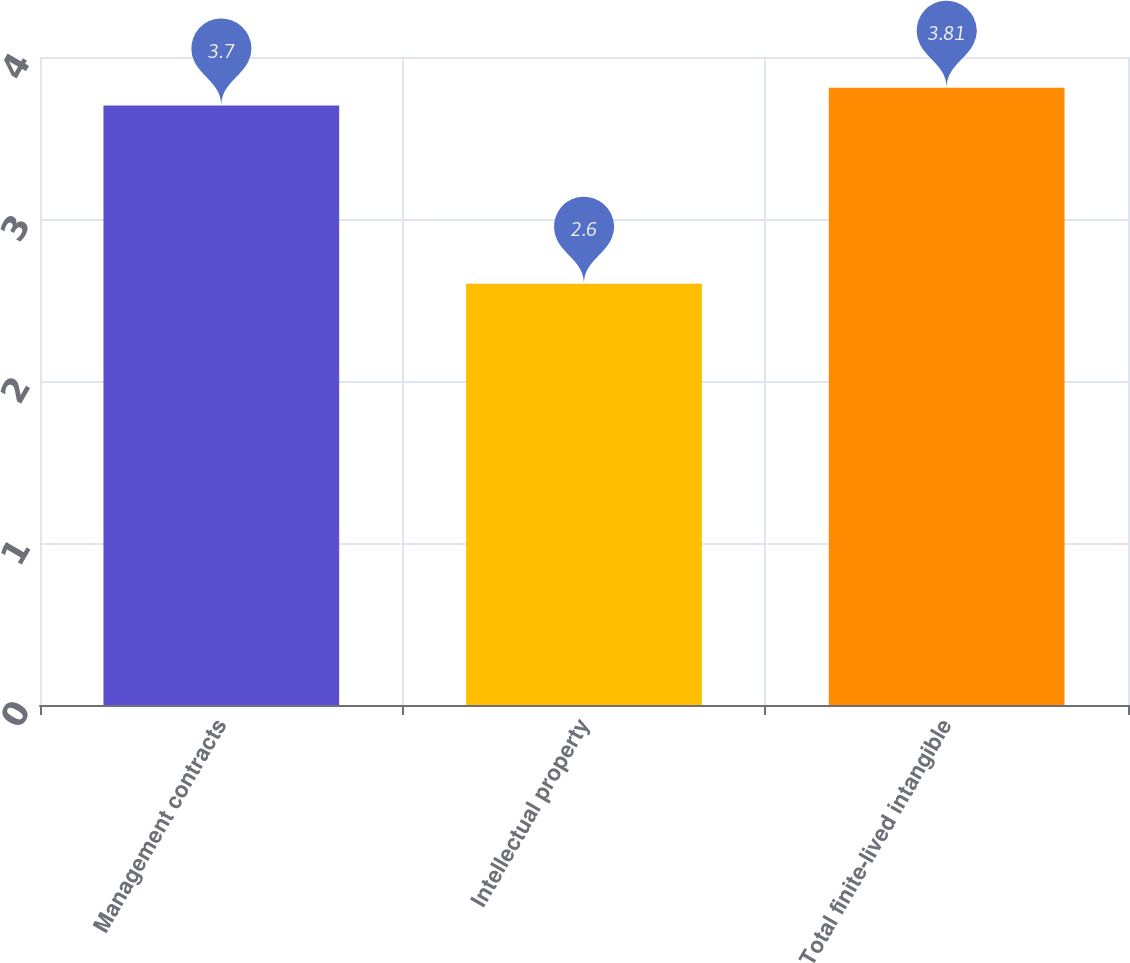Convert chart to OTSL. <chart><loc_0><loc_0><loc_500><loc_500><bar_chart><fcel>Management contracts<fcel>Intellectual property<fcel>Total finite-lived intangible<nl><fcel>3.7<fcel>2.6<fcel>3.81<nl></chart> 